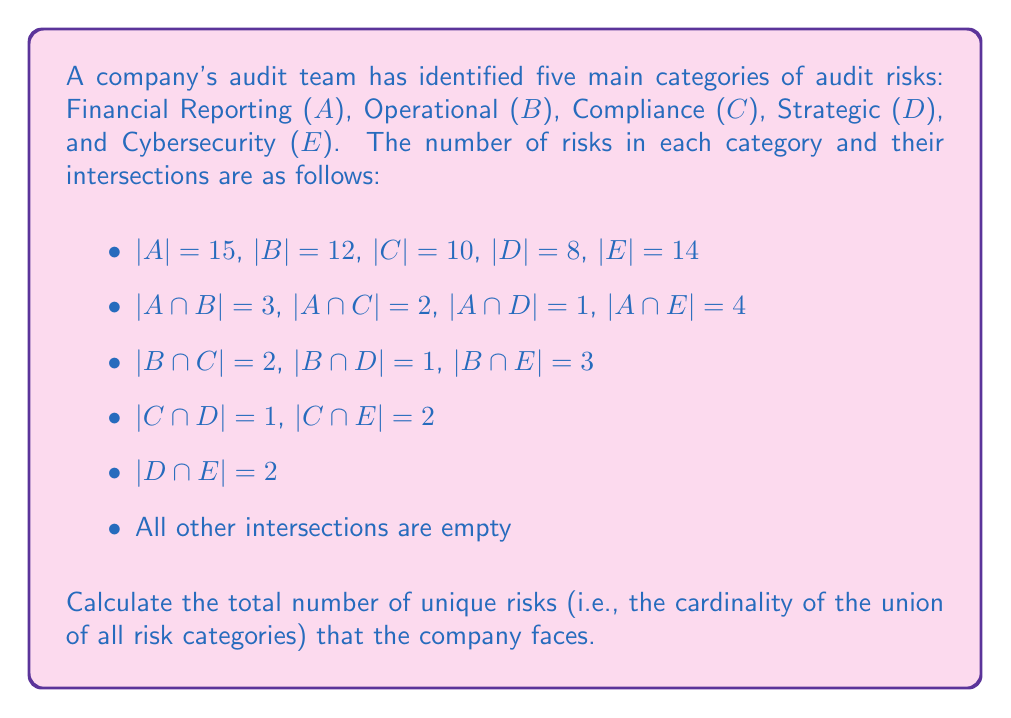Teach me how to tackle this problem. To solve this problem, we'll use the Inclusion-Exclusion Principle for five sets. The formula for the union of five sets is:

$$|A \cup B \cup C \cup D \cup E| = |A| + |B| + |C| + |D| + |E|$$
$$- (|A \cap B| + |A \cap C| + |A \cap D| + |A \cap E| + |B \cap C| + |B \cap D| + |B \cap E| + |C \cap D| + |C \cap E| + |D \cap E|)$$
$$+ (|A \cap B \cap C| + |A \cap B \cap D| + |A \cap B \cap E| + |A \cap C \cap D| + |A \cap C \cap E| + |A \cap D \cap E| + |B \cap C \cap D| + |B \cap C \cap E| + |B \cap D \cap E| + |C \cap D \cap E|)$$
$$- (|A \cap B \cap C \cap D| + |A \cap B \cap C \cap E| + |A \cap B \cap D \cap E| + |A \cap C \cap D \cap E| + |B \cap C \cap D \cap E|)$$
$$+ |A \cap B \cap C \cap D \cap E|$$

Let's substitute the given values:

1. Sum of individual sets:
   $15 + 12 + 10 + 8 + 14 = 59$

2. Sum of two-set intersections:
   $3 + 2 + 1 + 4 + 2 + 1 + 3 + 1 + 2 + 2 = 21$

3. Sum of three-set intersections and above:
   All these terms are 0 as we're told all other intersections are empty.

Now, let's apply the formula:

$$|A \cup B \cup C \cup D \cup E| = 59 - 21 + 0 - 0 + 0 = 38$$

Therefore, the total number of unique risks is 38.
Answer: 38 